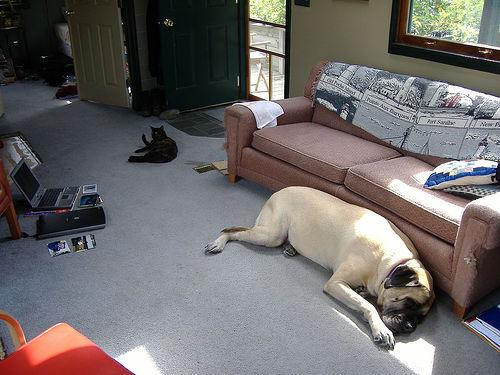Describe any surface or flooring details that can be seen in the image. There is a gray carpet on the floor, and a patch of tile near the open door. What kind of animals are in the image and what are they doing? A large tan dog is sleeping on the floor, and a black cat is lying on a gray carpet. Describe the appearance and position of any doors or windows in the image. A door in front is open, and there is a window behind the couch. A knob on the door and possibly a handle on the window is visible. Count the number of cushions or pillows visible in the image and describe them. There are at least two cushions or pillows, including a white and blue cushion on the couch and a blue and white pillow on the sofa. What kind of electronic device can be found in the image, and where is it placed? A laptop computer can be seen on the floor, possibly on a carpet. List the different items found on the floor in the image. A large tan dog, a black cat, a laptop computer, and compact disk case with CDs are on the floor. What type of item might be spread or hanging on a couch or sofa? A throw or blanket might be spread or hanging on the couch, possibly a white towel too. What type of seating can be seen in the image other than the couch, and what is its distinct feature? There is an edge of a red chair, possibly with wooden arms, and a wooden chair on a balcony. What is the primary piece of furniture seen in the image and what is on it? A couch, with a white and blue cushion and a throw spread on it, possibly a white towel too. Identify any reading materials that might be present in the image. There are a few books on the floor, possibly near the couch. Can you spot a delicious bowl of pet food in the image? It must be what keeps the pets so satisfied. No bowls of pet food are mentioned among the objects detected in the image, so this instruction distracts the viewer with a nonexistent item. Find the small green plant sitting on the window sill and observe its unique leaves. No plants, green or otherwise, have been mentioned in the list of objects. This adds another element to the scene that is not present. There is a stack of colorful books near the laptop, which one has the most interesting cover? While there are books mentioned in the list of objects detected, they are described as being on the floor and not specifically near the laptop. Furthermore, the colors are not mentioned, adding a false detail. Notice the big red ball in the corner of the room, it seems to be a popular toy for the pets. No red ball is mentioned among the objects, so this creates a false detail for the user to look for. Take a look at the beautiful painting hanging on the wall behind the couch, doesn't it match the room perfectly? No paintings are found in the list of objects detected in the image, misleading the user with an object that doesn't exist in the scene. Can you count how many stuffed animals are in the scene? There are at least three different colors to spot. There are no mentions of any stuffed animals in the list of objects detected in the image, so this instruction introduces a nonexistent object. 